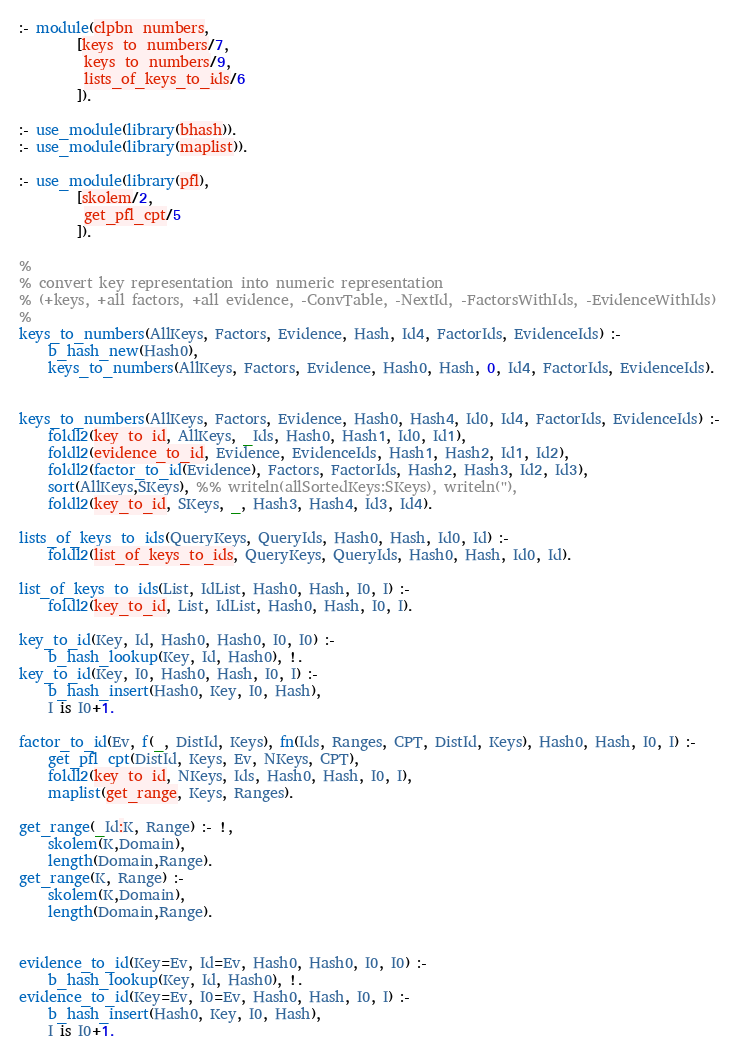<code> <loc_0><loc_0><loc_500><loc_500><_Prolog_>
:- module(clpbn_numbers,
		[keys_to_numbers/7,
		 keys_to_numbers/9,
		 lists_of_keys_to_ids/6
		]).

:- use_module(library(bhash)).
:- use_module(library(maplist)).

:- use_module(library(pfl),
		[skolem/2,
		 get_pfl_cpt/5
		]).

%
% convert key representation into numeric representation
% (+keys, +all factors, +all evidence, -ConvTable, -NextId, -FactorsWithIds, -EvidenceWithIds)
%
keys_to_numbers(AllKeys, Factors, Evidence, Hash, Id4, FactorIds, EvidenceIds) :-
	b_hash_new(Hash0),
	keys_to_numbers(AllKeys, Factors, Evidence, Hash0, Hash, 0, Id4, FactorIds, EvidenceIds).


keys_to_numbers(AllKeys, Factors, Evidence, Hash0, Hash4, Id0, Id4, FactorIds, EvidenceIds) :-
	foldl2(key_to_id, AllKeys, _Ids, Hash0, Hash1, Id0, Id1),
	foldl2(evidence_to_id, Evidence, EvidenceIds, Hash1, Hash2, Id1, Id2),
	foldl2(factor_to_id(Evidence), Factors, FactorIds, Hash2, Hash3, Id2, Id3),
	sort(AllKeys,SKeys), %% writeln(allSortedKeys:SKeys), writeln(''),
	foldl2(key_to_id, SKeys, _, Hash3, Hash4, Id3, Id4).

lists_of_keys_to_ids(QueryKeys, QueryIds, Hash0, Hash, Id0, Id) :-
	foldl2(list_of_keys_to_ids, QueryKeys, QueryIds, Hash0, Hash, Id0, Id).

list_of_keys_to_ids(List, IdList, Hash0, Hash, I0, I) :-
	foldl2(key_to_id, List, IdList, Hash0, Hash, I0, I).

key_to_id(Key, Id, Hash0, Hash0, I0, I0) :-
	b_hash_lookup(Key, Id, Hash0), !.
key_to_id(Key, I0, Hash0, Hash, I0, I) :-
	b_hash_insert(Hash0, Key, I0, Hash),
	I is I0+1.

factor_to_id(Ev, f(_, DistId, Keys), fn(Ids, Ranges, CPT, DistId, Keys), Hash0, Hash, I0, I) :-
	get_pfl_cpt(DistId, Keys, Ev, NKeys, CPT),
	foldl2(key_to_id, NKeys, Ids, Hash0, Hash, I0, I),
	maplist(get_range, Keys, Ranges).

get_range(_Id:K, Range) :- !,
	skolem(K,Domain),
	length(Domain,Range).
get_range(K, Range) :-
	skolem(K,Domain),
	length(Domain,Range).


evidence_to_id(Key=Ev, Id=Ev, Hash0, Hash0, I0, I0) :-
	b_hash_lookup(Key, Id, Hash0), !.
evidence_to_id(Key=Ev, I0=Ev, Hash0, Hash, I0, I) :-
	b_hash_insert(Hash0, Key, I0, Hash),
	I is I0+1.

</code> 